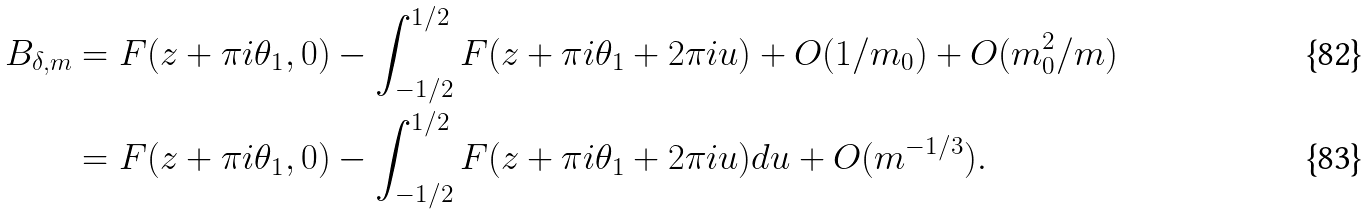<formula> <loc_0><loc_0><loc_500><loc_500>B _ { \delta , m } & = F ( z + \pi i \theta _ { 1 } , 0 ) - \int _ { - 1 / 2 } ^ { 1 / 2 } F ( z + \pi i \theta _ { 1 } + 2 \pi i u ) + O ( 1 / m _ { 0 } ) + O ( m _ { 0 } ^ { 2 } / m ) \\ & = F ( z + \pi i \theta _ { 1 } , 0 ) - \int _ { - 1 / 2 } ^ { 1 / 2 } F ( z + \pi i \theta _ { 1 } + 2 \pi i u ) d u + O ( m ^ { - 1 / 3 } ) .</formula> 